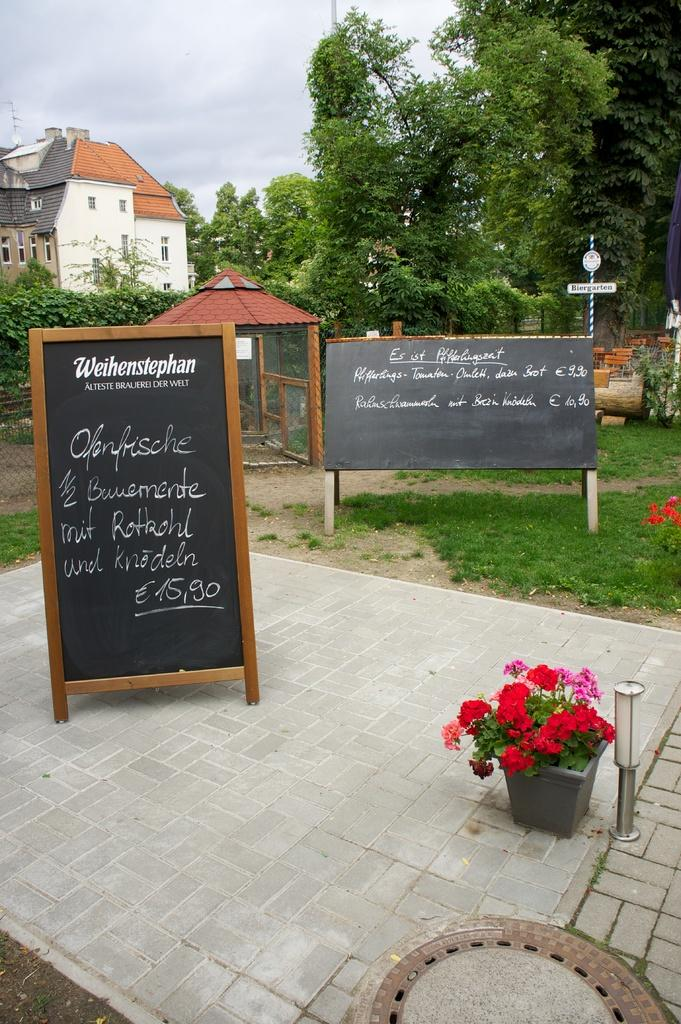What type of structures can be seen in the image? There are buildings in the image. What type of vegetation is present in the image? There are trees and grass visible in the image. What type of objects can be seen supporting wires or signs in the image? There are poles in the image. What type of signage is present in the image? There are information boards in the image. What type of plants can be seen inside the buildings in the image? There are house plants in the image. What type of lighting is present in the image? There are electric lights in the image. What part of the natural environment is visible in the image? The sky is visible in the image. What language is the person speaking in the image? There is no person speaking in the image, so it is not possible to determine the language being spoken. Can you describe the bite marks on the tree in the image? There are no bite marks visible on the trees in the image. 